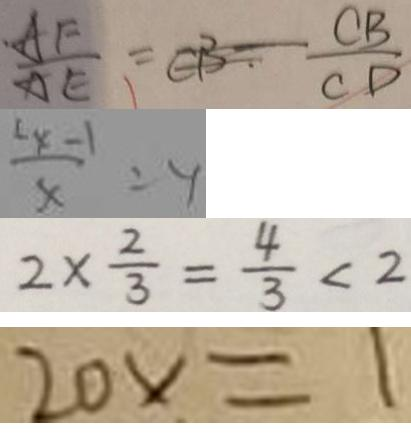<formula> <loc_0><loc_0><loc_500><loc_500>\frac { A F } { A E } = C B - \frac { C B } { C D } 
 \frac { x - 1 } { x } = y 
 2 \times \frac { 2 } { 3 } = \frac { 4 } { 3 } < 2 
 2 0 x = 1</formula> 